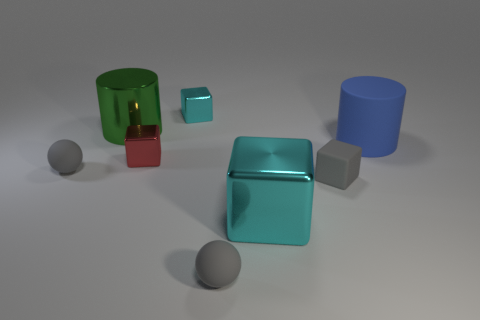Are there more yellow shiny blocks than blue matte objects?
Your answer should be very brief. No. What is the size of the object that is the same color as the big metal block?
Your response must be concise. Small. Are there any tiny cyan cubes made of the same material as the large green thing?
Your response must be concise. Yes. There is a big thing that is behind the small red block and to the right of the green metal cylinder; what shape is it?
Give a very brief answer. Cylinder. How many other things are the same shape as the red metallic thing?
Offer a very short reply. 3. What is the size of the red thing?
Your answer should be very brief. Small. How many objects are blue matte objects or balls?
Your answer should be very brief. 3. What is the size of the gray rubber object behind the tiny matte block?
Offer a terse response. Small. Are there any other things that are the same size as the red shiny block?
Provide a succinct answer. Yes. What is the color of the big thing that is both behind the small red metal thing and on the right side of the big green cylinder?
Ensure brevity in your answer.  Blue. 